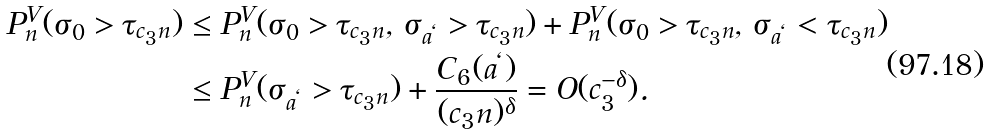<formula> <loc_0><loc_0><loc_500><loc_500>P ^ { V } _ { n } ( \sigma _ { 0 } > \tau _ { c _ { 3 } n } ) & \leq P ^ { V } _ { n } ( \sigma _ { 0 } > \tau _ { c _ { 3 } n } , \, \sigma _ { a ^ { \ell } } > \tau _ { c _ { 3 } n } ) + P ^ { V } _ { n } ( \sigma _ { 0 } > \tau _ { c _ { 3 } n } , \, \sigma _ { a ^ { \ell } } < \tau _ { c _ { 3 } n } ) \\ & \leq P ^ { V } _ { n } ( \sigma _ { a ^ { \ell } } > \tau _ { c _ { 3 } n } ) + \frac { C _ { 6 } ( a ^ { \ell } ) } { ( c _ { 3 } n ) ^ { \delta } } = O ( c _ { 3 } ^ { - \delta } ) .</formula> 